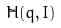Convert formula to latex. <formula><loc_0><loc_0><loc_500><loc_500>\tilde { H } ( q , I )</formula> 